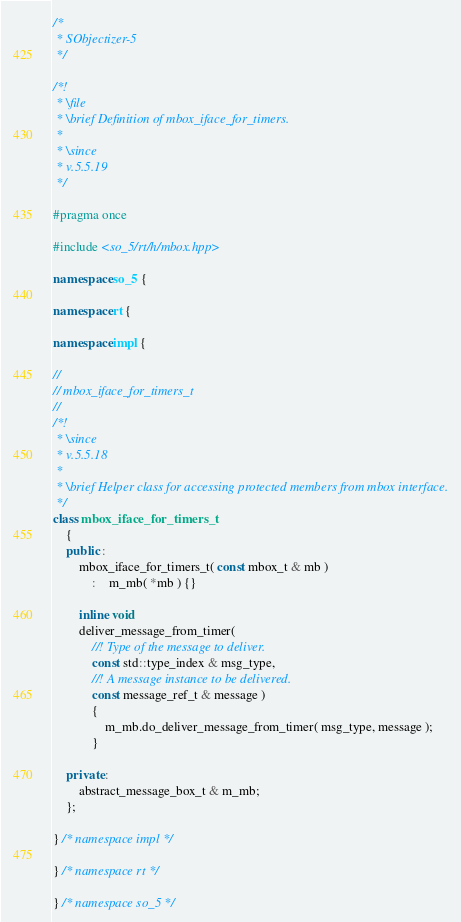<code> <loc_0><loc_0><loc_500><loc_500><_C++_>/*
 * SObjectizer-5
 */

/*!
 * \file
 * \brief Definition of mbox_iface_for_timers.
 *
 * \since
 * v.5.5.19
 */

#pragma once

#include <so_5/rt/h/mbox.hpp>

namespace so_5 {

namespace rt {

namespace impl {

//
// mbox_iface_for_timers_t
//
/*!
 * \since
 * v.5.5.18
 *
 * \brief Helper class for accessing protected members from mbox interface.
 */
class mbox_iface_for_timers_t
	{
	public :
		mbox_iface_for_timers_t( const mbox_t & mb )
			:	m_mb( *mb ) {}

		inline void
		deliver_message_from_timer(
			//! Type of the message to deliver.
			const std::type_index & msg_type,
			//! A message instance to be delivered.
			const message_ref_t & message )
			{
				m_mb.do_deliver_message_from_timer( msg_type, message );
			}

	private :
		abstract_message_box_t & m_mb;
	};

} /* namespace impl */

} /* namespace rt */

} /* namespace so_5 */


</code> 